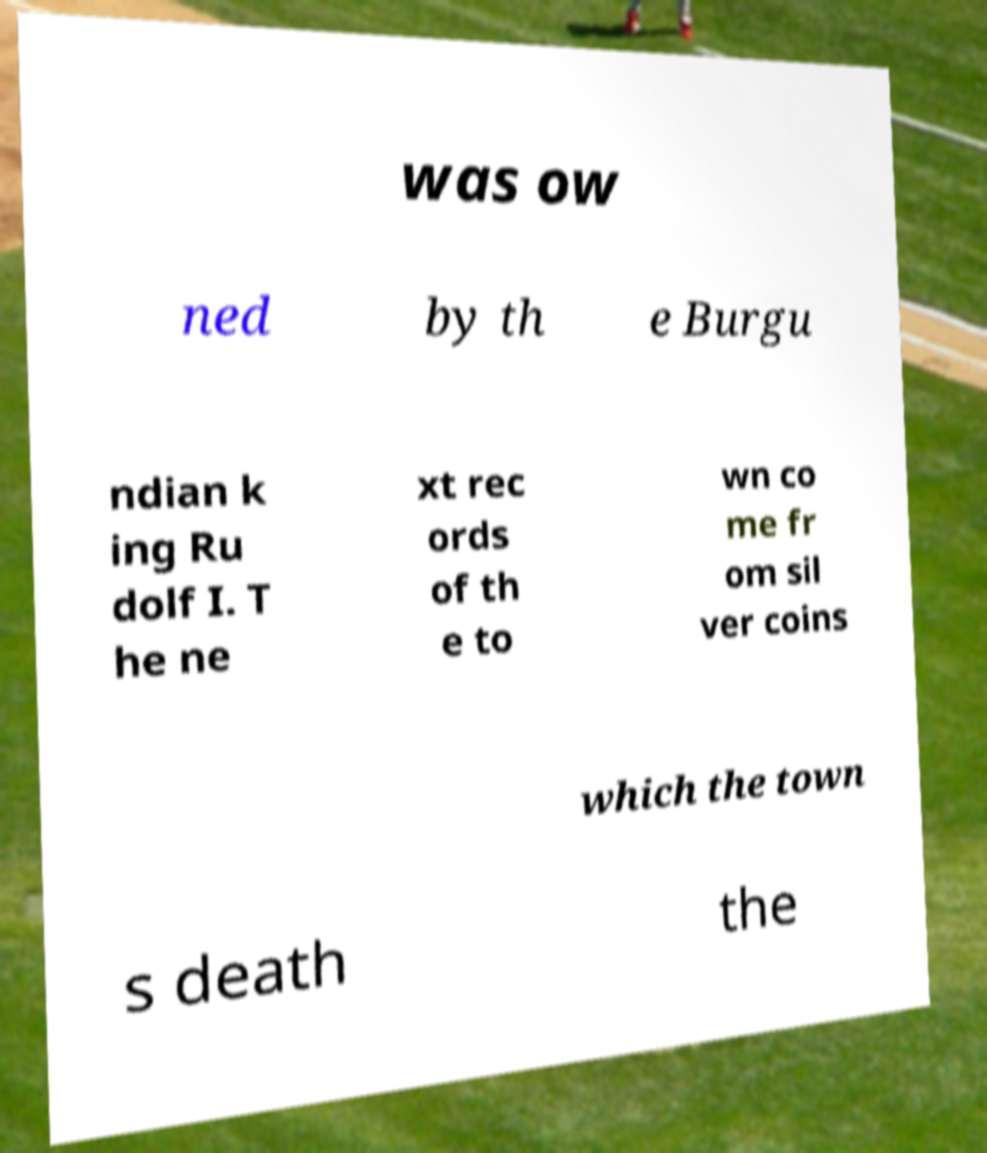There's text embedded in this image that I need extracted. Can you transcribe it verbatim? was ow ned by th e Burgu ndian k ing Ru dolf I. T he ne xt rec ords of th e to wn co me fr om sil ver coins which the town s death the 